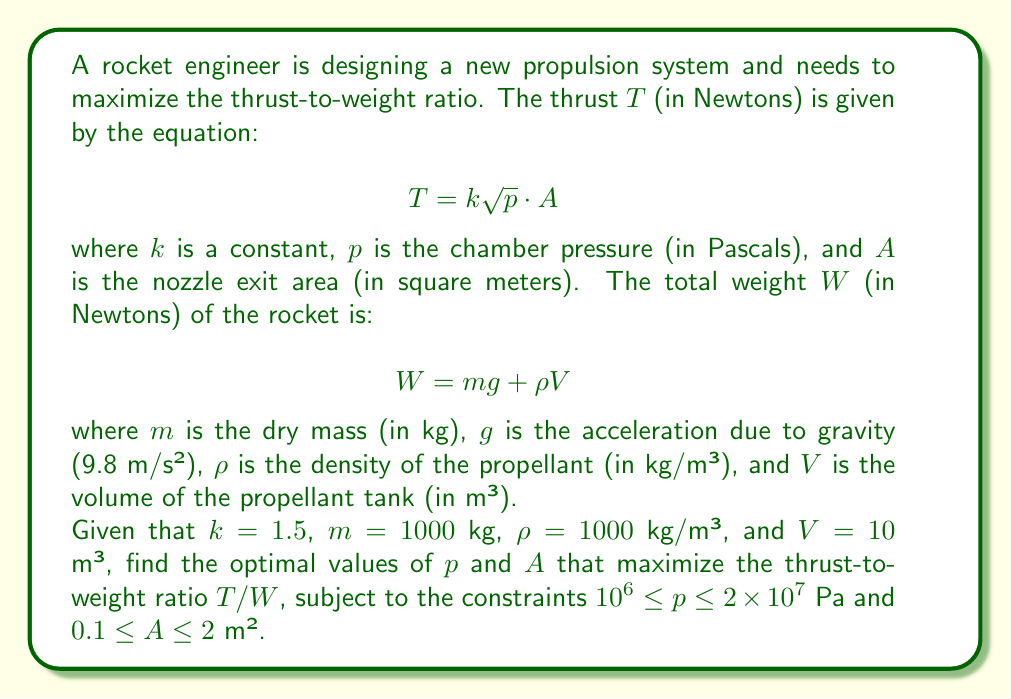Could you help me with this problem? To solve this optimization problem, we'll follow these steps:

1) First, let's express the thrust-to-weight ratio $T/W$ in terms of $p$ and $A$:

   $$\frac{T}{W} = \frac{k\sqrt{p}A}{mg + \rho V}$$

2) Substituting the given values:

   $$\frac{T}{W} = \frac{1.5\sqrt{p}A}{1000 \cdot 9.8 + 1000 \cdot 10} = \frac{1.5\sqrt{p}A}{19800}$$

3) To maximize this function, we need to find the partial derivatives with respect to $p$ and $A$ and set them to zero:

   $$\frac{\partial}{\partial p}\left(\frac{T}{W}\right) = \frac{1.5A}{2\sqrt{p} \cdot 19800} = 0$$
   $$\frac{\partial}{\partial A}\left(\frac{T}{W}\right) = \frac{1.5\sqrt{p}}{19800} = 0$$

4) However, setting these to zero doesn't yield meaningful results within our constraints. This suggests that the maximum occurs at the boundary of our constraint region.

5) Let's evaluate the function at the corners of our constraint region:

   At $(p,A) = (10^6, 0.1)$: $\frac{T}{W} \approx 0.0076$
   At $(p,A) = (10^6, 2)$: $\frac{T}{W} \approx 0.1515$
   At $(p,A) = (2 \times 10^7, 0.1)$: $\frac{T}{W} \approx 0.0339$
   At $(p,A) = (2 \times 10^7, 2)$: $\frac{T}{W} \approx 0.6778$

6) The maximum value occurs at the point $(2 \times 10^7, 2)$, which corresponds to the maximum allowed values for both $p$ and $A$.

Therefore, the optimal values are $p = 2 \times 10^7$ Pa and $A = 2$ m², yielding a maximum thrust-to-weight ratio of approximately 0.6778.
Answer: $p = 2 \times 10^7$ Pa, $A = 2$ m² 